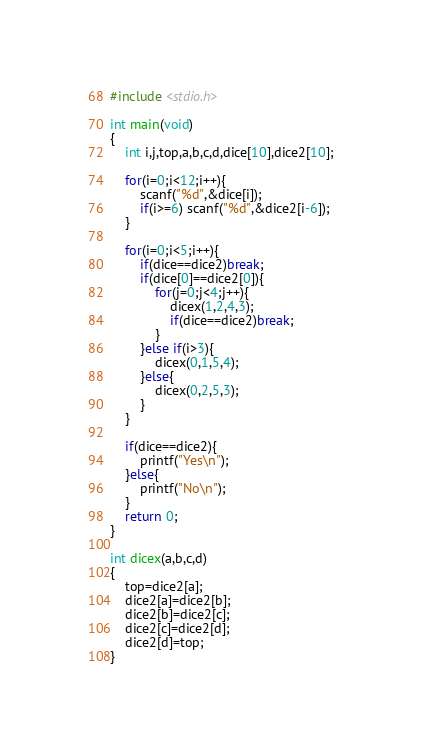<code> <loc_0><loc_0><loc_500><loc_500><_C_>#include <stdio.h>

int main(void)
{
    int i,j,top,a,b,c,d,dice[10],dice2[10];
    
    for(i=0;i<12;i++){
        scanf("%d",&dice[i]);
        if(i>=6) scanf("%d",&dice2[i-6]);
    }
    
    for(i=0;i<5;i++){
        if(dice==dice2)break;
        if(dice[0]==dice2[0]){
            for(j=0;j<4;j++){
                dicex(1,2,4,3);
                if(dice==dice2)break;
            }
        }else if(i>3){
            dicex(0,1,5,4);
        }else{
            dicex(0,2,5,3);
        }
    }
    
    if(dice==dice2){
        printf("Yes\n");
    }else{
        printf("No\n");
    }
    return 0;
}

int dicex(a,b,c,d)
{
    top=dice2[a];
    dice2[a]=dice2[b];
    dice2[b]=dice2[c];
    dice2[c]=dice2[d];
    dice2[d]=top;
}

</code> 